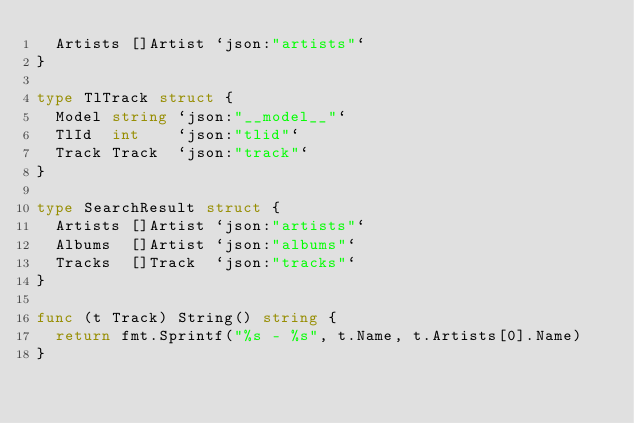Convert code to text. <code><loc_0><loc_0><loc_500><loc_500><_Go_>	Artists []Artist `json:"artists"`
}

type TlTrack struct {
	Model string `json:"__model__"`
	TlId  int    `json:"tlid"`
	Track Track  `json:"track"`
}

type SearchResult struct {
	Artists []Artist `json:"artists"`
	Albums  []Artist `json:"albums"`
	Tracks  []Track  `json:"tracks"`
}

func (t Track) String() string {
	return fmt.Sprintf("%s - %s", t.Name, t.Artists[0].Name)
}
</code> 